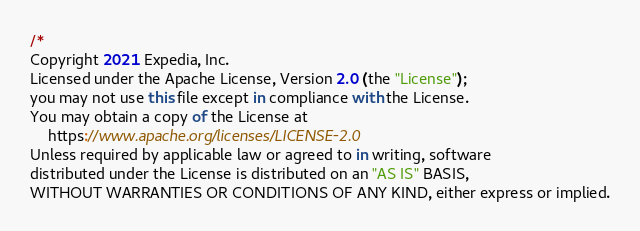Convert code to text. <code><loc_0><loc_0><loc_500><loc_500><_TypeScript_>/*
Copyright 2021 Expedia, Inc.
Licensed under the Apache License, Version 2.0 (the "License");
you may not use this file except in compliance with the License.
You may obtain a copy of the License at
    https://www.apache.org/licenses/LICENSE-2.0
Unless required by applicable law or agreed to in writing, software
distributed under the License is distributed on an "AS IS" BASIS,
WITHOUT WARRANTIES OR CONDITIONS OF ANY KIND, either express or implied.</code> 